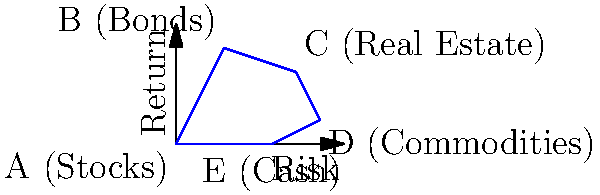As a financial advisor, you're analyzing different asset allocations for a client. The graph represents various asset classes plotted on a risk-return plane. Points A, B, C, D, and E represent Stocks, Bonds, Real Estate, Commodities, and Cash, respectively. Calculate the area of the polygon formed by connecting these points to determine the diversity of the portfolio allocation. Use the coordinates: A(0,0), B(2,4), C(5,3), D(6,1), and E(4,0). To find the area of the irregular polygon, we can use the Shoelace formula (also known as the surveyor's formula). The steps are as follows:

1) The Shoelace formula for a polygon with vertices $(x_1, y_1), (x_2, y_2), ..., (x_n, y_n)$ is:

   Area = $\frac{1}{2}|((x_1y_2 + x_2y_3 + ... + x_ny_1) - (y_1x_2 + y_2x_3 + ... + y_nx_1))|$

2) Substituting our coordinates:
   A(0,0), B(2,4), C(5,3), D(6,1), E(4,0)

3) Applying the formula:

   Area = $\frac{1}{2}|((0 \cdot 4 + 2 \cdot 3 + 5 \cdot 1 + 6 \cdot 0 + 4 \cdot 0) - (0 \cdot 2 + 4 \cdot 5 + 3 \cdot 6 + 1 \cdot 4 + 0 \cdot 0))|$

4) Simplifying:
   
   Area = $\frac{1}{2}|((0 + 6 + 5 + 0 + 0) - (0 + 20 + 18 + 4 + 0))|$
   
   Area = $\frac{1}{2}|(11 - 42)|$
   
   Area = $\frac{1}{2}(31)$
   
   Area = 15.5

Therefore, the area of the polygon representing the diverse asset allocation is 15.5 square units.
Answer: 15.5 square units 